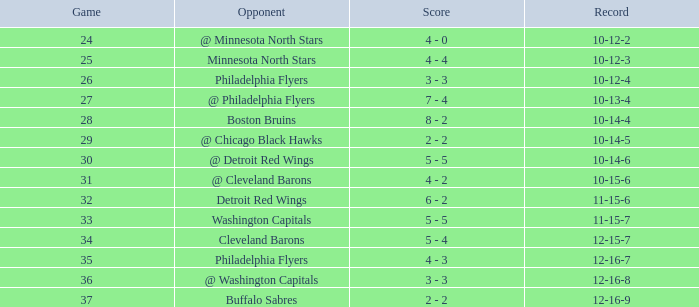What is Record, when Game is "24"? 10-12-2. 